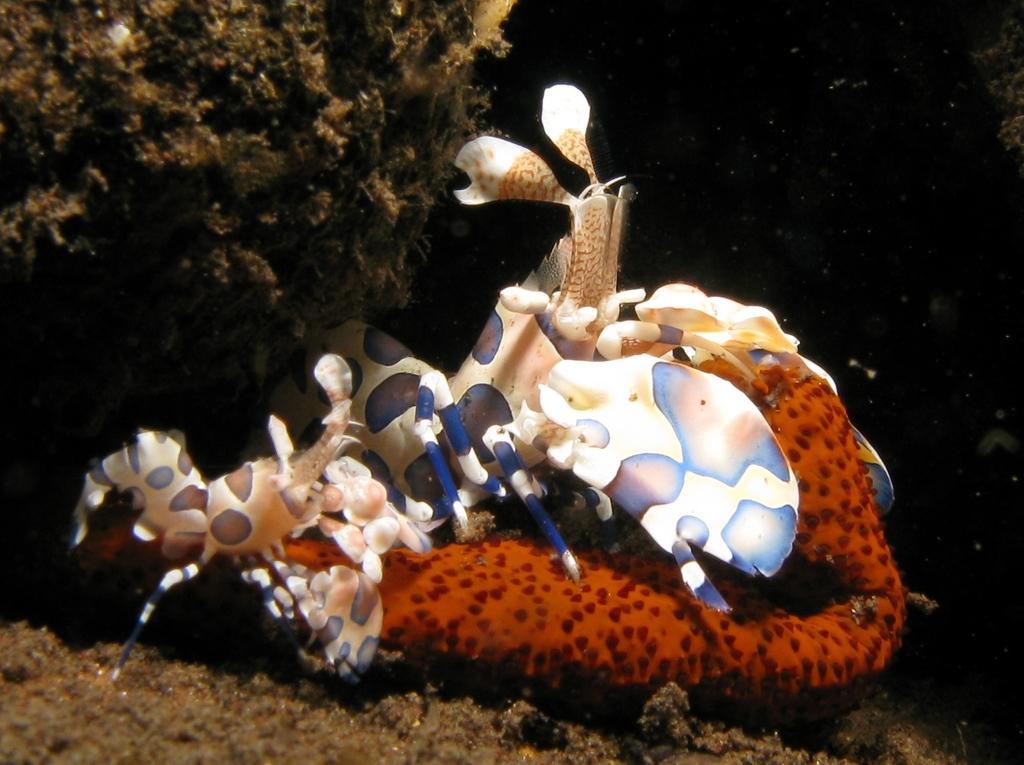Could you give a brief overview of what you see in this image? In this image, we can see an object and there are some trees. 